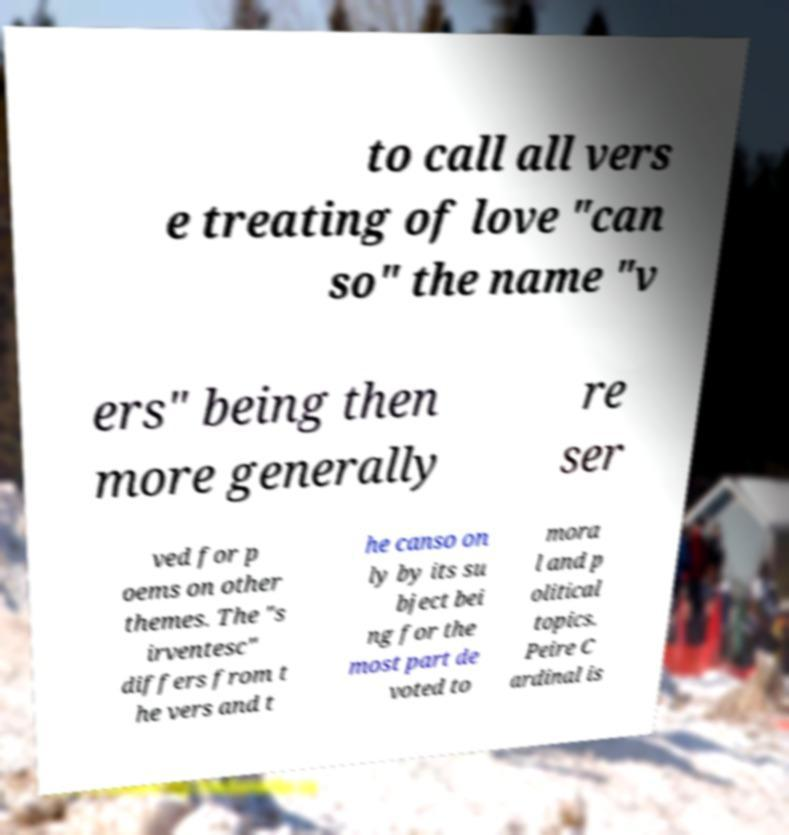Can you read and provide the text displayed in the image?This photo seems to have some interesting text. Can you extract and type it out for me? to call all vers e treating of love "can so" the name "v ers" being then more generally re ser ved for p oems on other themes. The "s irventesc" differs from t he vers and t he canso on ly by its su bject bei ng for the most part de voted to mora l and p olitical topics. Peire C ardinal is 